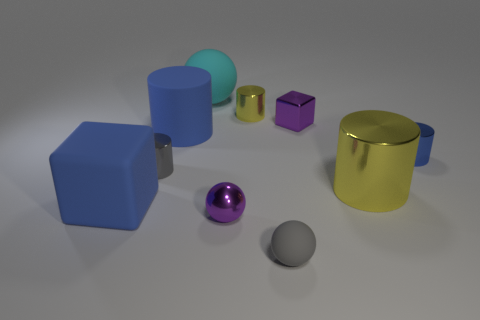There is a big blue object that is in front of the metallic cylinder that is to the left of the cyan matte thing; what is it made of?
Keep it short and to the point. Rubber. Is there anything else that has the same size as the blue cube?
Give a very brief answer. Yes. Do the blue matte block and the gray matte object have the same size?
Make the answer very short. No. What number of objects are either objects behind the tiny purple shiny sphere or tiny balls that are in front of the big yellow metal thing?
Offer a very short reply. 10. Is the number of big blue cylinders in front of the large cube greater than the number of small yellow cylinders?
Provide a short and direct response. No. What number of other objects are there of the same shape as the blue metal thing?
Offer a very short reply. 4. The cylinder that is behind the blue metallic cylinder and to the right of the cyan sphere is made of what material?
Ensure brevity in your answer.  Metal. What number of objects are small purple metallic spheres or large cyan metallic spheres?
Keep it short and to the point. 1. Is the number of purple metallic cubes greater than the number of cubes?
Your answer should be very brief. No. There is a blue cylinder right of the purple metallic object in front of the tiny gray metal cylinder; what is its size?
Give a very brief answer. Small. 